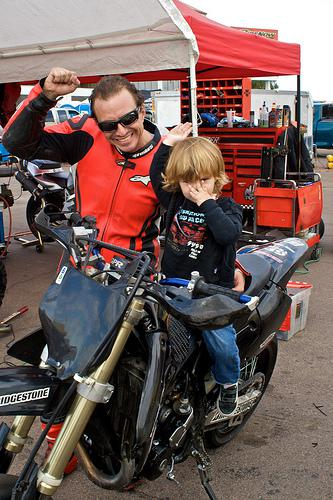Question: when was the picture taken?
Choices:
A. While the boy was sitting on the motorcycle.
B. While the girl was eating.
C. At midnight.
D. Sunrise.
Answer with the letter. Answer: A Question: how many people are in the image?
Choices:
A. Four.
B. Five.
C. Six.
D. Two.
Answer with the letter. Answer: D Question: who is in the picture?
Choices:
A. A man and a little boy.
B. A woman.
C. A girl and her dog.
D. A family.
Answer with the letter. Answer: A Question: what color is the man's vest?
Choices:
A. Black.
B. Orange and black.
C. White.
D. Pink.
Answer with the letter. Answer: B Question: why is the little boy covering his face?
Choices:
A. He is scared.
B. He doesn't want his picture taken.
C. He is posing for a picture.
D. He is ugly.
Answer with the letter. Answer: C 